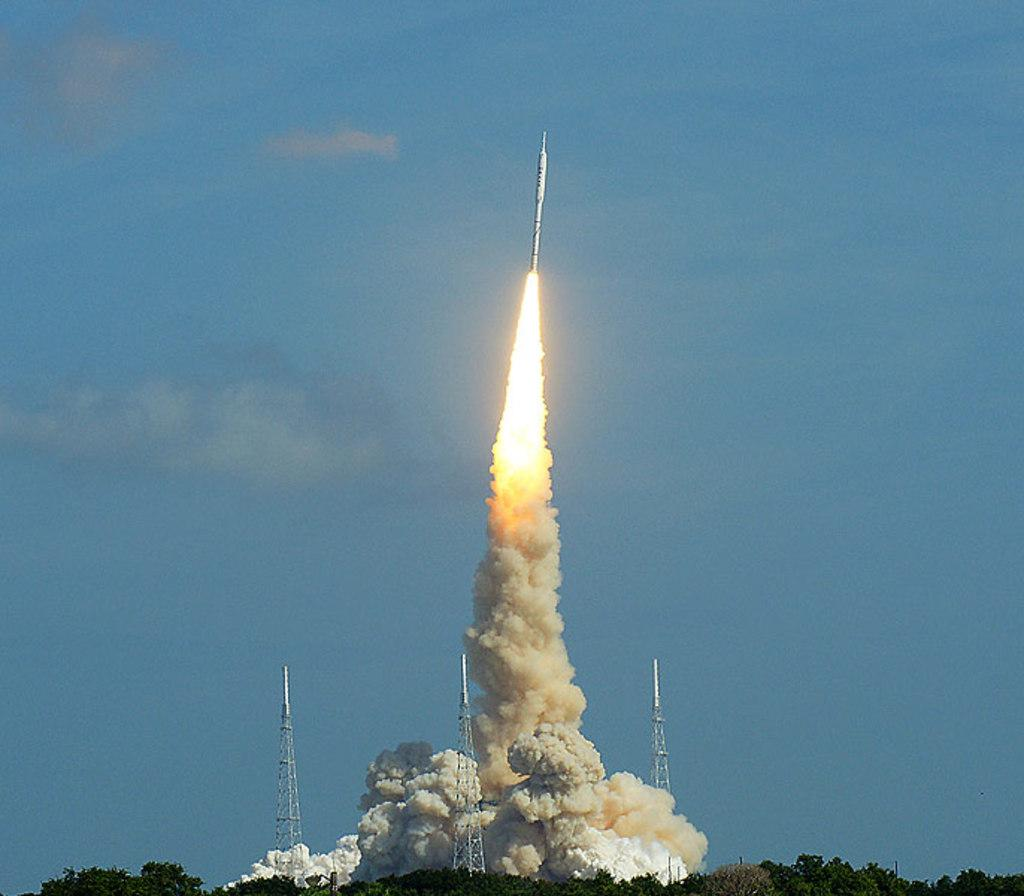What type of vegetation can be seen in the image? There are trees in the image. What structures are present in the image? There are towers in the image. What is the object visible at the top of the image? There is a rocket visible at the top of the image. What can be seen in the sky in the image? Clouds are present in the sky. What type of wool is being harvested from the trees in the image? There is no wool being harvested from the trees in the image; it features trees, towers, a rocket, and clouds. Can you see any corn growing in the image? There is no corn visible in the image. 